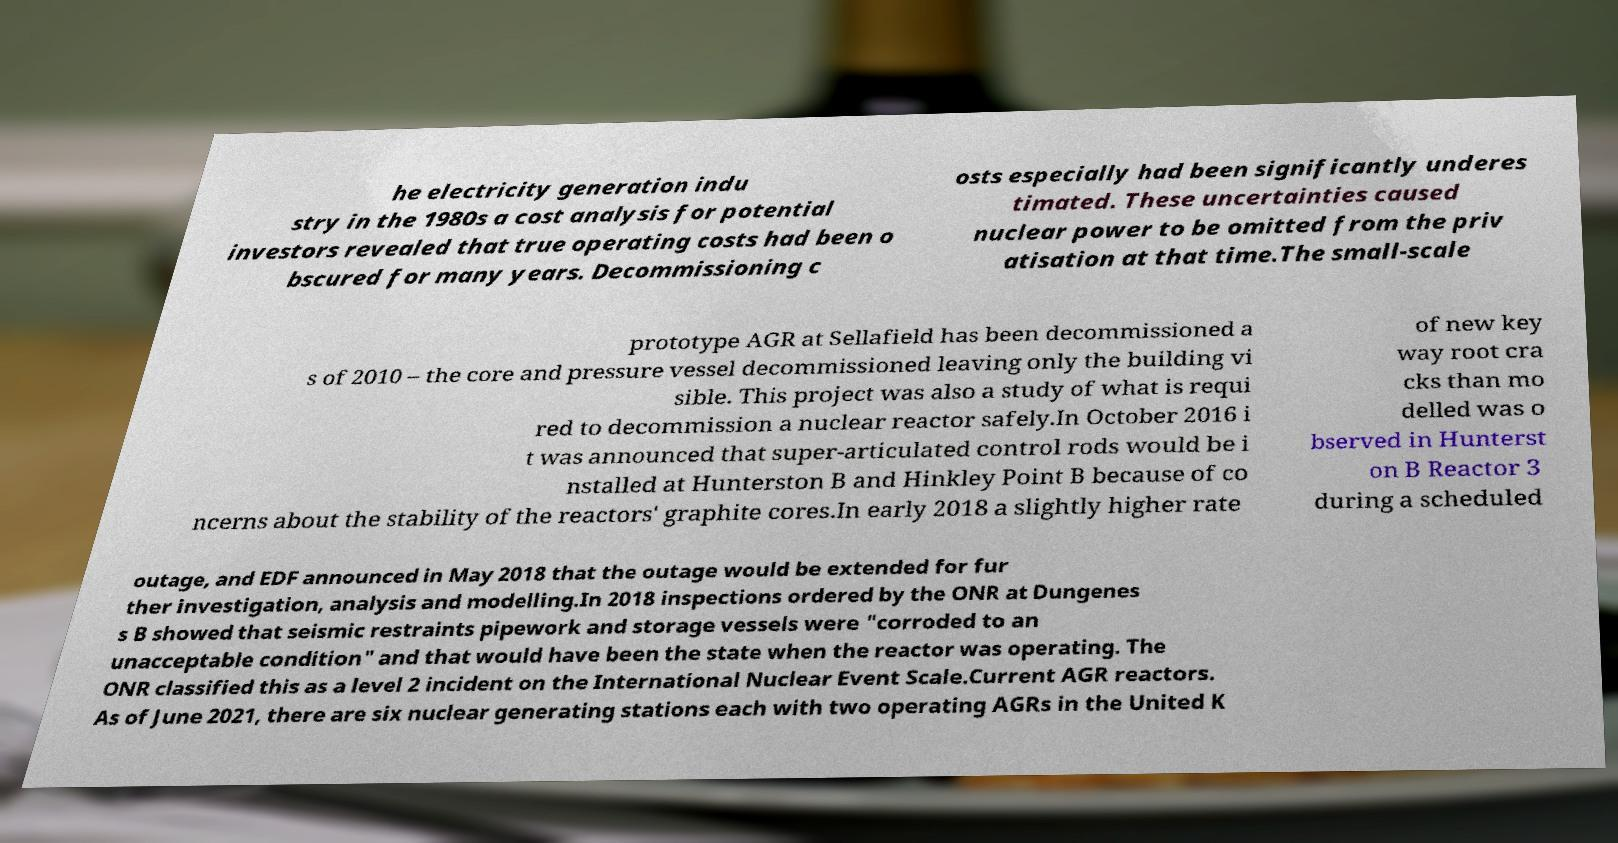What messages or text are displayed in this image? I need them in a readable, typed format. he electricity generation indu stry in the 1980s a cost analysis for potential investors revealed that true operating costs had been o bscured for many years. Decommissioning c osts especially had been significantly underes timated. These uncertainties caused nuclear power to be omitted from the priv atisation at that time.The small-scale prototype AGR at Sellafield has been decommissioned a s of 2010 – the core and pressure vessel decommissioned leaving only the building vi sible. This project was also a study of what is requi red to decommission a nuclear reactor safely.In October 2016 i t was announced that super-articulated control rods would be i nstalled at Hunterston B and Hinkley Point B because of co ncerns about the stability of the reactors' graphite cores.In early 2018 a slightly higher rate of new key way root cra cks than mo delled was o bserved in Hunterst on B Reactor 3 during a scheduled outage, and EDF announced in May 2018 that the outage would be extended for fur ther investigation, analysis and modelling.In 2018 inspections ordered by the ONR at Dungenes s B showed that seismic restraints pipework and storage vessels were "corroded to an unacceptable condition" and that would have been the state when the reactor was operating. The ONR classified this as a level 2 incident on the International Nuclear Event Scale.Current AGR reactors. As of June 2021, there are six nuclear generating stations each with two operating AGRs in the United K 